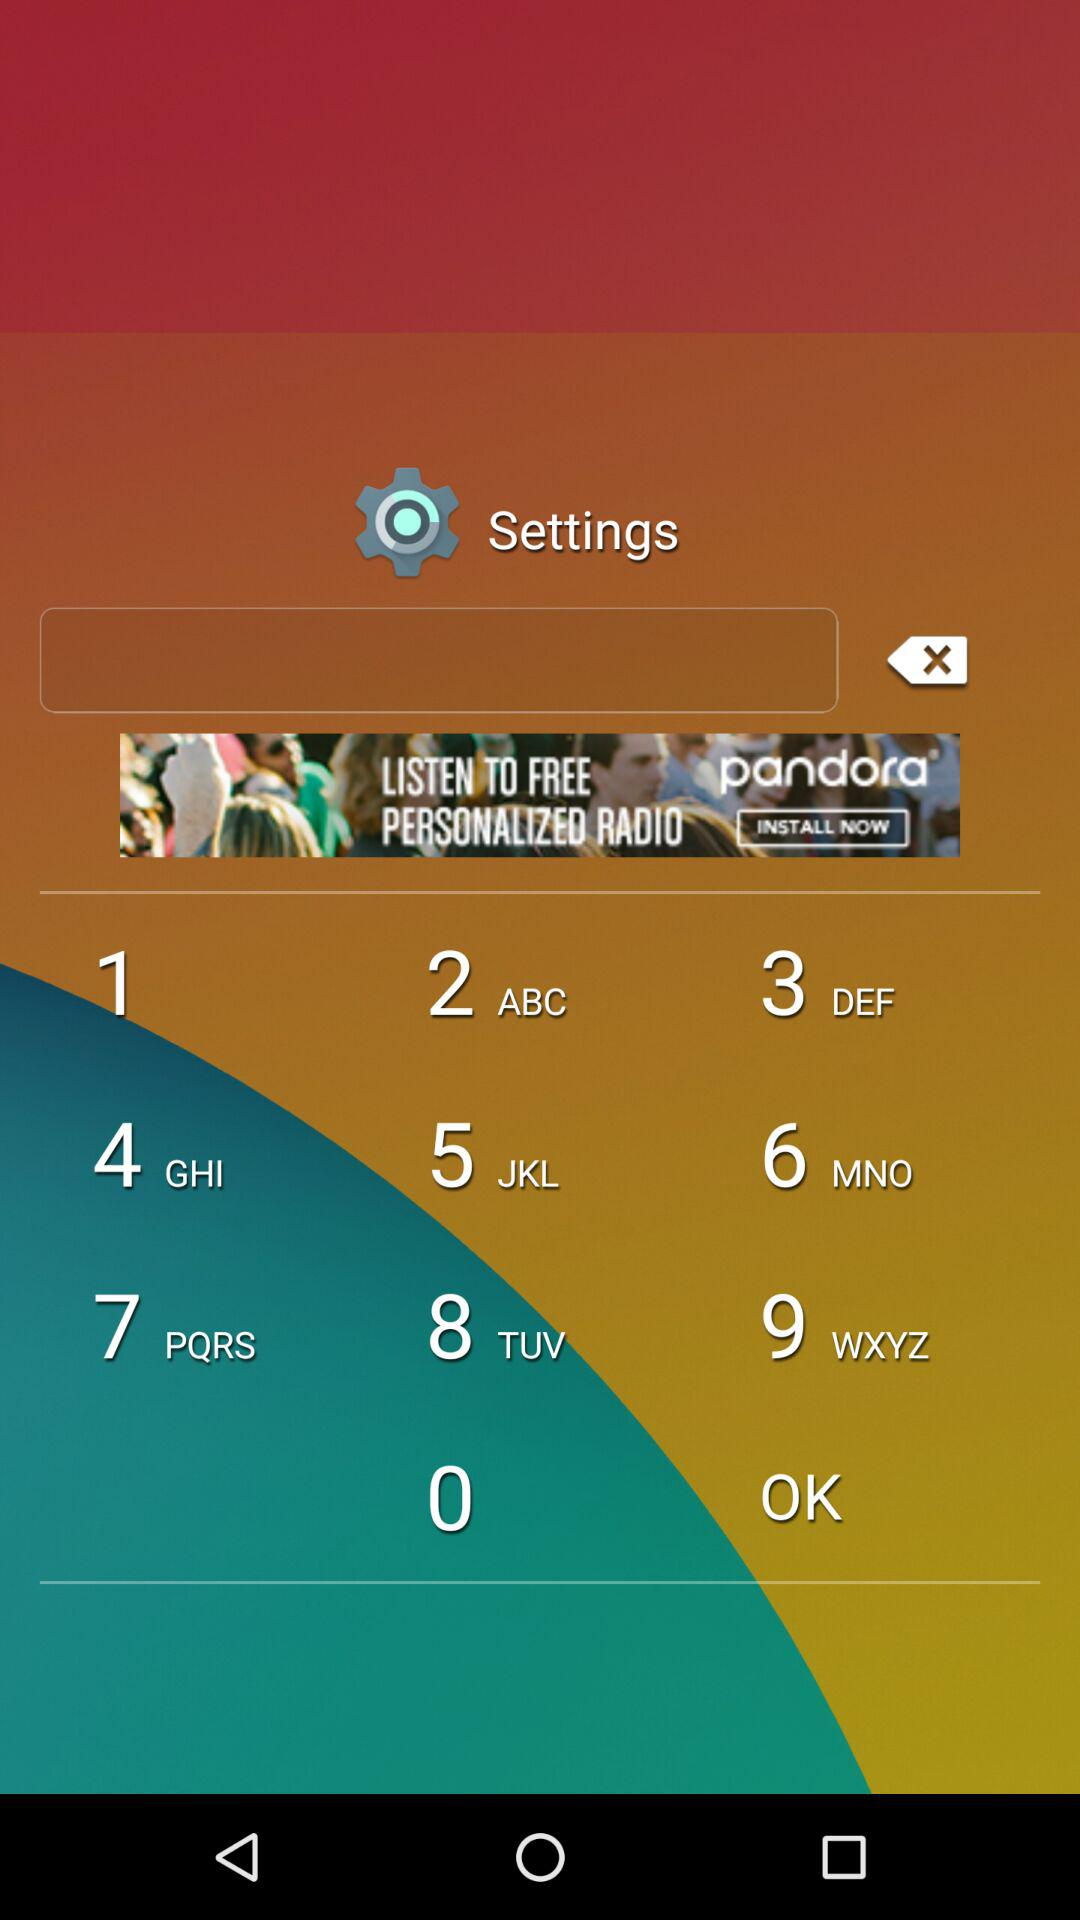What is the selected tab? The selected tab is "Measure". 